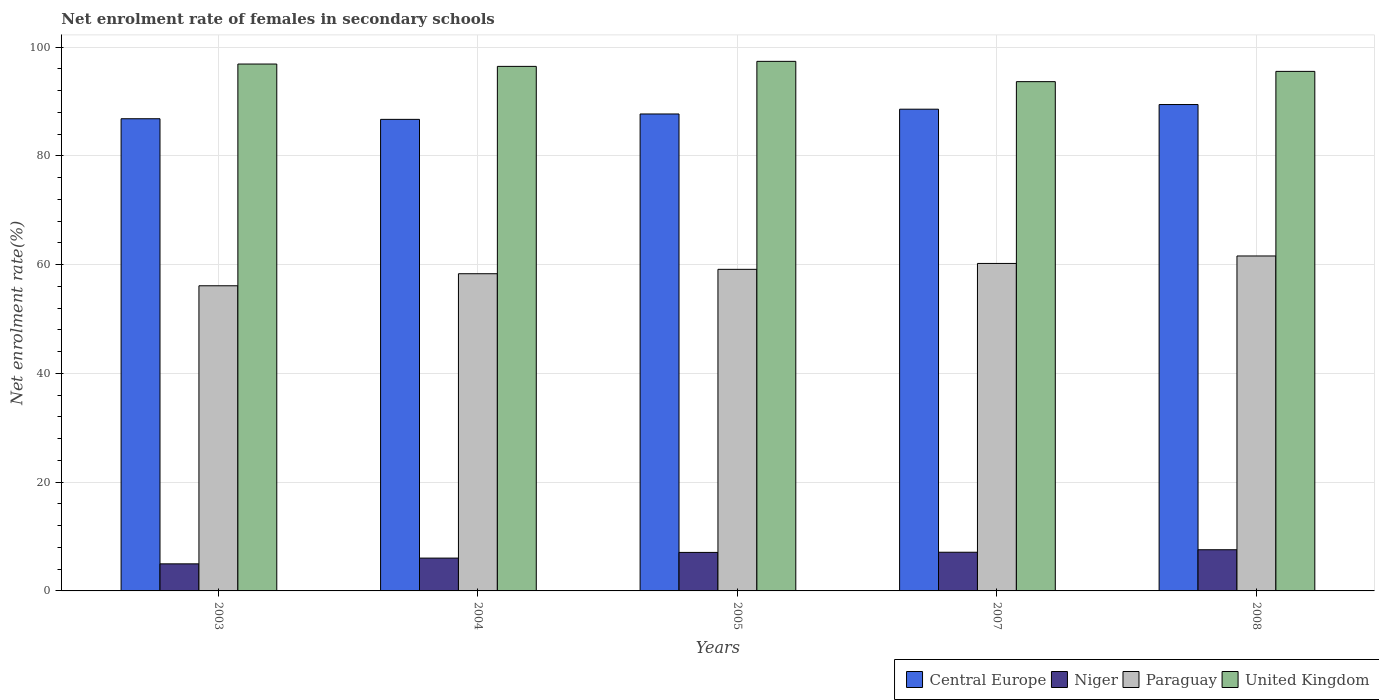Are the number of bars on each tick of the X-axis equal?
Your answer should be very brief. Yes. How many bars are there on the 2nd tick from the right?
Offer a terse response. 4. What is the label of the 4th group of bars from the left?
Your response must be concise. 2007. In how many cases, is the number of bars for a given year not equal to the number of legend labels?
Give a very brief answer. 0. What is the net enrolment rate of females in secondary schools in United Kingdom in 2004?
Offer a terse response. 96.44. Across all years, what is the maximum net enrolment rate of females in secondary schools in Paraguay?
Give a very brief answer. 61.59. Across all years, what is the minimum net enrolment rate of females in secondary schools in Paraguay?
Your answer should be compact. 56.11. In which year was the net enrolment rate of females in secondary schools in United Kingdom minimum?
Provide a short and direct response. 2007. What is the total net enrolment rate of females in secondary schools in United Kingdom in the graph?
Keep it short and to the point. 479.85. What is the difference between the net enrolment rate of females in secondary schools in United Kingdom in 2007 and that in 2008?
Provide a succinct answer. -1.89. What is the difference between the net enrolment rate of females in secondary schools in Paraguay in 2005 and the net enrolment rate of females in secondary schools in Niger in 2004?
Keep it short and to the point. 53.09. What is the average net enrolment rate of females in secondary schools in Central Europe per year?
Make the answer very short. 87.84. In the year 2003, what is the difference between the net enrolment rate of females in secondary schools in Paraguay and net enrolment rate of females in secondary schools in Niger?
Make the answer very short. 51.13. In how many years, is the net enrolment rate of females in secondary schools in Central Europe greater than 72 %?
Provide a succinct answer. 5. What is the ratio of the net enrolment rate of females in secondary schools in Niger in 2004 to that in 2007?
Provide a short and direct response. 0.85. Is the net enrolment rate of females in secondary schools in Paraguay in 2004 less than that in 2005?
Offer a terse response. Yes. Is the difference between the net enrolment rate of females in secondary schools in Paraguay in 2004 and 2005 greater than the difference between the net enrolment rate of females in secondary schools in Niger in 2004 and 2005?
Your answer should be very brief. Yes. What is the difference between the highest and the second highest net enrolment rate of females in secondary schools in Niger?
Your answer should be very brief. 0.46. What is the difference between the highest and the lowest net enrolment rate of females in secondary schools in Central Europe?
Your answer should be compact. 2.73. Is the sum of the net enrolment rate of females in secondary schools in Paraguay in 2005 and 2007 greater than the maximum net enrolment rate of females in secondary schools in Niger across all years?
Your answer should be very brief. Yes. Is it the case that in every year, the sum of the net enrolment rate of females in secondary schools in United Kingdom and net enrolment rate of females in secondary schools in Paraguay is greater than the sum of net enrolment rate of females in secondary schools in Niger and net enrolment rate of females in secondary schools in Central Europe?
Offer a very short reply. Yes. What does the 2nd bar from the left in 2008 represents?
Give a very brief answer. Niger. What does the 3rd bar from the right in 2003 represents?
Provide a short and direct response. Niger. How many years are there in the graph?
Your answer should be very brief. 5. What is the difference between two consecutive major ticks on the Y-axis?
Provide a short and direct response. 20. Are the values on the major ticks of Y-axis written in scientific E-notation?
Offer a very short reply. No. Does the graph contain grids?
Ensure brevity in your answer.  Yes. How many legend labels are there?
Your answer should be very brief. 4. What is the title of the graph?
Offer a very short reply. Net enrolment rate of females in secondary schools. Does "Central Europe" appear as one of the legend labels in the graph?
Provide a succinct answer. Yes. What is the label or title of the Y-axis?
Provide a succinct answer. Net enrolment rate(%). What is the Net enrolment rate(%) of Central Europe in 2003?
Ensure brevity in your answer.  86.82. What is the Net enrolment rate(%) of Niger in 2003?
Your response must be concise. 4.98. What is the Net enrolment rate(%) in Paraguay in 2003?
Provide a succinct answer. 56.11. What is the Net enrolment rate(%) in United Kingdom in 2003?
Your answer should be very brief. 96.88. What is the Net enrolment rate(%) in Central Europe in 2004?
Offer a very short reply. 86.7. What is the Net enrolment rate(%) in Niger in 2004?
Provide a short and direct response. 6.04. What is the Net enrolment rate(%) of Paraguay in 2004?
Keep it short and to the point. 58.32. What is the Net enrolment rate(%) in United Kingdom in 2004?
Your answer should be very brief. 96.44. What is the Net enrolment rate(%) of Central Europe in 2005?
Your answer should be very brief. 87.69. What is the Net enrolment rate(%) in Niger in 2005?
Give a very brief answer. 7.08. What is the Net enrolment rate(%) in Paraguay in 2005?
Offer a very short reply. 59.13. What is the Net enrolment rate(%) in United Kingdom in 2005?
Give a very brief answer. 97.37. What is the Net enrolment rate(%) in Central Europe in 2007?
Your answer should be very brief. 88.57. What is the Net enrolment rate(%) of Niger in 2007?
Ensure brevity in your answer.  7.11. What is the Net enrolment rate(%) of Paraguay in 2007?
Ensure brevity in your answer.  60.21. What is the Net enrolment rate(%) of United Kingdom in 2007?
Provide a short and direct response. 93.64. What is the Net enrolment rate(%) of Central Europe in 2008?
Provide a short and direct response. 89.43. What is the Net enrolment rate(%) of Niger in 2008?
Offer a very short reply. 7.57. What is the Net enrolment rate(%) of Paraguay in 2008?
Offer a very short reply. 61.59. What is the Net enrolment rate(%) of United Kingdom in 2008?
Your answer should be compact. 95.53. Across all years, what is the maximum Net enrolment rate(%) of Central Europe?
Your response must be concise. 89.43. Across all years, what is the maximum Net enrolment rate(%) of Niger?
Make the answer very short. 7.57. Across all years, what is the maximum Net enrolment rate(%) of Paraguay?
Your answer should be very brief. 61.59. Across all years, what is the maximum Net enrolment rate(%) in United Kingdom?
Provide a short and direct response. 97.37. Across all years, what is the minimum Net enrolment rate(%) of Central Europe?
Make the answer very short. 86.7. Across all years, what is the minimum Net enrolment rate(%) in Niger?
Give a very brief answer. 4.98. Across all years, what is the minimum Net enrolment rate(%) of Paraguay?
Offer a terse response. 56.11. Across all years, what is the minimum Net enrolment rate(%) of United Kingdom?
Keep it short and to the point. 93.64. What is the total Net enrolment rate(%) of Central Europe in the graph?
Provide a succinct answer. 439.22. What is the total Net enrolment rate(%) of Niger in the graph?
Offer a terse response. 32.78. What is the total Net enrolment rate(%) of Paraguay in the graph?
Provide a short and direct response. 295.35. What is the total Net enrolment rate(%) of United Kingdom in the graph?
Provide a short and direct response. 479.85. What is the difference between the Net enrolment rate(%) of Central Europe in 2003 and that in 2004?
Ensure brevity in your answer.  0.12. What is the difference between the Net enrolment rate(%) in Niger in 2003 and that in 2004?
Give a very brief answer. -1.06. What is the difference between the Net enrolment rate(%) in Paraguay in 2003 and that in 2004?
Your answer should be compact. -2.22. What is the difference between the Net enrolment rate(%) in United Kingdom in 2003 and that in 2004?
Your answer should be compact. 0.43. What is the difference between the Net enrolment rate(%) of Central Europe in 2003 and that in 2005?
Your answer should be compact. -0.88. What is the difference between the Net enrolment rate(%) of Niger in 2003 and that in 2005?
Offer a very short reply. -2.1. What is the difference between the Net enrolment rate(%) of Paraguay in 2003 and that in 2005?
Provide a short and direct response. -3.02. What is the difference between the Net enrolment rate(%) in United Kingdom in 2003 and that in 2005?
Keep it short and to the point. -0.49. What is the difference between the Net enrolment rate(%) in Central Europe in 2003 and that in 2007?
Your response must be concise. -1.76. What is the difference between the Net enrolment rate(%) of Niger in 2003 and that in 2007?
Keep it short and to the point. -2.13. What is the difference between the Net enrolment rate(%) of Paraguay in 2003 and that in 2007?
Your answer should be compact. -4.1. What is the difference between the Net enrolment rate(%) in United Kingdom in 2003 and that in 2007?
Offer a very short reply. 3.24. What is the difference between the Net enrolment rate(%) of Central Europe in 2003 and that in 2008?
Offer a terse response. -2.61. What is the difference between the Net enrolment rate(%) in Niger in 2003 and that in 2008?
Provide a short and direct response. -2.6. What is the difference between the Net enrolment rate(%) of Paraguay in 2003 and that in 2008?
Offer a terse response. -5.48. What is the difference between the Net enrolment rate(%) in United Kingdom in 2003 and that in 2008?
Ensure brevity in your answer.  1.35. What is the difference between the Net enrolment rate(%) of Central Europe in 2004 and that in 2005?
Your answer should be compact. -0.99. What is the difference between the Net enrolment rate(%) in Niger in 2004 and that in 2005?
Offer a very short reply. -1.05. What is the difference between the Net enrolment rate(%) in Paraguay in 2004 and that in 2005?
Keep it short and to the point. -0.81. What is the difference between the Net enrolment rate(%) in United Kingdom in 2004 and that in 2005?
Your response must be concise. -0.93. What is the difference between the Net enrolment rate(%) in Central Europe in 2004 and that in 2007?
Your answer should be very brief. -1.87. What is the difference between the Net enrolment rate(%) of Niger in 2004 and that in 2007?
Offer a very short reply. -1.08. What is the difference between the Net enrolment rate(%) of Paraguay in 2004 and that in 2007?
Your response must be concise. -1.89. What is the difference between the Net enrolment rate(%) of United Kingdom in 2004 and that in 2007?
Your response must be concise. 2.81. What is the difference between the Net enrolment rate(%) in Central Europe in 2004 and that in 2008?
Offer a terse response. -2.73. What is the difference between the Net enrolment rate(%) of Niger in 2004 and that in 2008?
Provide a short and direct response. -1.54. What is the difference between the Net enrolment rate(%) in Paraguay in 2004 and that in 2008?
Your answer should be compact. -3.26. What is the difference between the Net enrolment rate(%) of United Kingdom in 2004 and that in 2008?
Your answer should be compact. 0.92. What is the difference between the Net enrolment rate(%) in Central Europe in 2005 and that in 2007?
Your answer should be very brief. -0.88. What is the difference between the Net enrolment rate(%) in Niger in 2005 and that in 2007?
Your answer should be compact. -0.03. What is the difference between the Net enrolment rate(%) in Paraguay in 2005 and that in 2007?
Offer a terse response. -1.08. What is the difference between the Net enrolment rate(%) of United Kingdom in 2005 and that in 2007?
Make the answer very short. 3.73. What is the difference between the Net enrolment rate(%) of Central Europe in 2005 and that in 2008?
Offer a very short reply. -1.74. What is the difference between the Net enrolment rate(%) of Niger in 2005 and that in 2008?
Give a very brief answer. -0.49. What is the difference between the Net enrolment rate(%) of Paraguay in 2005 and that in 2008?
Provide a succinct answer. -2.46. What is the difference between the Net enrolment rate(%) of United Kingdom in 2005 and that in 2008?
Keep it short and to the point. 1.84. What is the difference between the Net enrolment rate(%) of Central Europe in 2007 and that in 2008?
Offer a very short reply. -0.86. What is the difference between the Net enrolment rate(%) of Niger in 2007 and that in 2008?
Your response must be concise. -0.46. What is the difference between the Net enrolment rate(%) of Paraguay in 2007 and that in 2008?
Offer a very short reply. -1.38. What is the difference between the Net enrolment rate(%) in United Kingdom in 2007 and that in 2008?
Provide a succinct answer. -1.89. What is the difference between the Net enrolment rate(%) in Central Europe in 2003 and the Net enrolment rate(%) in Niger in 2004?
Provide a succinct answer. 80.78. What is the difference between the Net enrolment rate(%) of Central Europe in 2003 and the Net enrolment rate(%) of Paraguay in 2004?
Your response must be concise. 28.5. What is the difference between the Net enrolment rate(%) of Central Europe in 2003 and the Net enrolment rate(%) of United Kingdom in 2004?
Provide a succinct answer. -9.63. What is the difference between the Net enrolment rate(%) in Niger in 2003 and the Net enrolment rate(%) in Paraguay in 2004?
Your answer should be compact. -53.35. What is the difference between the Net enrolment rate(%) of Niger in 2003 and the Net enrolment rate(%) of United Kingdom in 2004?
Provide a short and direct response. -91.47. What is the difference between the Net enrolment rate(%) in Paraguay in 2003 and the Net enrolment rate(%) in United Kingdom in 2004?
Offer a very short reply. -40.34. What is the difference between the Net enrolment rate(%) of Central Europe in 2003 and the Net enrolment rate(%) of Niger in 2005?
Make the answer very short. 79.74. What is the difference between the Net enrolment rate(%) in Central Europe in 2003 and the Net enrolment rate(%) in Paraguay in 2005?
Your answer should be compact. 27.69. What is the difference between the Net enrolment rate(%) of Central Europe in 2003 and the Net enrolment rate(%) of United Kingdom in 2005?
Your response must be concise. -10.55. What is the difference between the Net enrolment rate(%) in Niger in 2003 and the Net enrolment rate(%) in Paraguay in 2005?
Provide a succinct answer. -54.15. What is the difference between the Net enrolment rate(%) in Niger in 2003 and the Net enrolment rate(%) in United Kingdom in 2005?
Keep it short and to the point. -92.39. What is the difference between the Net enrolment rate(%) in Paraguay in 2003 and the Net enrolment rate(%) in United Kingdom in 2005?
Your answer should be compact. -41.26. What is the difference between the Net enrolment rate(%) of Central Europe in 2003 and the Net enrolment rate(%) of Niger in 2007?
Provide a short and direct response. 79.71. What is the difference between the Net enrolment rate(%) in Central Europe in 2003 and the Net enrolment rate(%) in Paraguay in 2007?
Your answer should be compact. 26.61. What is the difference between the Net enrolment rate(%) in Central Europe in 2003 and the Net enrolment rate(%) in United Kingdom in 2007?
Provide a short and direct response. -6.82. What is the difference between the Net enrolment rate(%) of Niger in 2003 and the Net enrolment rate(%) of Paraguay in 2007?
Offer a very short reply. -55.23. What is the difference between the Net enrolment rate(%) of Niger in 2003 and the Net enrolment rate(%) of United Kingdom in 2007?
Your response must be concise. -88.66. What is the difference between the Net enrolment rate(%) of Paraguay in 2003 and the Net enrolment rate(%) of United Kingdom in 2007?
Provide a short and direct response. -37.53. What is the difference between the Net enrolment rate(%) of Central Europe in 2003 and the Net enrolment rate(%) of Niger in 2008?
Ensure brevity in your answer.  79.25. What is the difference between the Net enrolment rate(%) in Central Europe in 2003 and the Net enrolment rate(%) in Paraguay in 2008?
Your answer should be compact. 25.23. What is the difference between the Net enrolment rate(%) in Central Europe in 2003 and the Net enrolment rate(%) in United Kingdom in 2008?
Your answer should be very brief. -8.71. What is the difference between the Net enrolment rate(%) in Niger in 2003 and the Net enrolment rate(%) in Paraguay in 2008?
Give a very brief answer. -56.61. What is the difference between the Net enrolment rate(%) in Niger in 2003 and the Net enrolment rate(%) in United Kingdom in 2008?
Provide a succinct answer. -90.55. What is the difference between the Net enrolment rate(%) in Paraguay in 2003 and the Net enrolment rate(%) in United Kingdom in 2008?
Give a very brief answer. -39.42. What is the difference between the Net enrolment rate(%) in Central Europe in 2004 and the Net enrolment rate(%) in Niger in 2005?
Give a very brief answer. 79.62. What is the difference between the Net enrolment rate(%) in Central Europe in 2004 and the Net enrolment rate(%) in Paraguay in 2005?
Provide a succinct answer. 27.57. What is the difference between the Net enrolment rate(%) in Central Europe in 2004 and the Net enrolment rate(%) in United Kingdom in 2005?
Provide a short and direct response. -10.67. What is the difference between the Net enrolment rate(%) in Niger in 2004 and the Net enrolment rate(%) in Paraguay in 2005?
Make the answer very short. -53.09. What is the difference between the Net enrolment rate(%) in Niger in 2004 and the Net enrolment rate(%) in United Kingdom in 2005?
Ensure brevity in your answer.  -91.33. What is the difference between the Net enrolment rate(%) of Paraguay in 2004 and the Net enrolment rate(%) of United Kingdom in 2005?
Your response must be concise. -39.05. What is the difference between the Net enrolment rate(%) in Central Europe in 2004 and the Net enrolment rate(%) in Niger in 2007?
Make the answer very short. 79.59. What is the difference between the Net enrolment rate(%) of Central Europe in 2004 and the Net enrolment rate(%) of Paraguay in 2007?
Provide a short and direct response. 26.49. What is the difference between the Net enrolment rate(%) in Central Europe in 2004 and the Net enrolment rate(%) in United Kingdom in 2007?
Your answer should be compact. -6.94. What is the difference between the Net enrolment rate(%) of Niger in 2004 and the Net enrolment rate(%) of Paraguay in 2007?
Your answer should be compact. -54.18. What is the difference between the Net enrolment rate(%) in Niger in 2004 and the Net enrolment rate(%) in United Kingdom in 2007?
Offer a terse response. -87.6. What is the difference between the Net enrolment rate(%) of Paraguay in 2004 and the Net enrolment rate(%) of United Kingdom in 2007?
Offer a very short reply. -35.32. What is the difference between the Net enrolment rate(%) in Central Europe in 2004 and the Net enrolment rate(%) in Niger in 2008?
Offer a terse response. 79.13. What is the difference between the Net enrolment rate(%) in Central Europe in 2004 and the Net enrolment rate(%) in Paraguay in 2008?
Keep it short and to the point. 25.12. What is the difference between the Net enrolment rate(%) of Central Europe in 2004 and the Net enrolment rate(%) of United Kingdom in 2008?
Make the answer very short. -8.82. What is the difference between the Net enrolment rate(%) of Niger in 2004 and the Net enrolment rate(%) of Paraguay in 2008?
Your response must be concise. -55.55. What is the difference between the Net enrolment rate(%) of Niger in 2004 and the Net enrolment rate(%) of United Kingdom in 2008?
Ensure brevity in your answer.  -89.49. What is the difference between the Net enrolment rate(%) in Paraguay in 2004 and the Net enrolment rate(%) in United Kingdom in 2008?
Make the answer very short. -37.2. What is the difference between the Net enrolment rate(%) in Central Europe in 2005 and the Net enrolment rate(%) in Niger in 2007?
Offer a very short reply. 80.58. What is the difference between the Net enrolment rate(%) in Central Europe in 2005 and the Net enrolment rate(%) in Paraguay in 2007?
Ensure brevity in your answer.  27.48. What is the difference between the Net enrolment rate(%) in Central Europe in 2005 and the Net enrolment rate(%) in United Kingdom in 2007?
Provide a short and direct response. -5.94. What is the difference between the Net enrolment rate(%) in Niger in 2005 and the Net enrolment rate(%) in Paraguay in 2007?
Make the answer very short. -53.13. What is the difference between the Net enrolment rate(%) in Niger in 2005 and the Net enrolment rate(%) in United Kingdom in 2007?
Provide a short and direct response. -86.56. What is the difference between the Net enrolment rate(%) in Paraguay in 2005 and the Net enrolment rate(%) in United Kingdom in 2007?
Offer a terse response. -34.51. What is the difference between the Net enrolment rate(%) in Central Europe in 2005 and the Net enrolment rate(%) in Niger in 2008?
Make the answer very short. 80.12. What is the difference between the Net enrolment rate(%) in Central Europe in 2005 and the Net enrolment rate(%) in Paraguay in 2008?
Provide a short and direct response. 26.11. What is the difference between the Net enrolment rate(%) of Central Europe in 2005 and the Net enrolment rate(%) of United Kingdom in 2008?
Ensure brevity in your answer.  -7.83. What is the difference between the Net enrolment rate(%) of Niger in 2005 and the Net enrolment rate(%) of Paraguay in 2008?
Provide a succinct answer. -54.51. What is the difference between the Net enrolment rate(%) of Niger in 2005 and the Net enrolment rate(%) of United Kingdom in 2008?
Your answer should be very brief. -88.44. What is the difference between the Net enrolment rate(%) in Paraguay in 2005 and the Net enrolment rate(%) in United Kingdom in 2008?
Your response must be concise. -36.4. What is the difference between the Net enrolment rate(%) in Central Europe in 2007 and the Net enrolment rate(%) in Niger in 2008?
Make the answer very short. 81. What is the difference between the Net enrolment rate(%) of Central Europe in 2007 and the Net enrolment rate(%) of Paraguay in 2008?
Give a very brief answer. 26.99. What is the difference between the Net enrolment rate(%) in Central Europe in 2007 and the Net enrolment rate(%) in United Kingdom in 2008?
Offer a very short reply. -6.95. What is the difference between the Net enrolment rate(%) of Niger in 2007 and the Net enrolment rate(%) of Paraguay in 2008?
Give a very brief answer. -54.48. What is the difference between the Net enrolment rate(%) in Niger in 2007 and the Net enrolment rate(%) in United Kingdom in 2008?
Your answer should be very brief. -88.41. What is the difference between the Net enrolment rate(%) in Paraguay in 2007 and the Net enrolment rate(%) in United Kingdom in 2008?
Your answer should be very brief. -35.31. What is the average Net enrolment rate(%) of Central Europe per year?
Make the answer very short. 87.84. What is the average Net enrolment rate(%) in Niger per year?
Your response must be concise. 6.56. What is the average Net enrolment rate(%) of Paraguay per year?
Provide a succinct answer. 59.07. What is the average Net enrolment rate(%) in United Kingdom per year?
Keep it short and to the point. 95.97. In the year 2003, what is the difference between the Net enrolment rate(%) of Central Europe and Net enrolment rate(%) of Niger?
Give a very brief answer. 81.84. In the year 2003, what is the difference between the Net enrolment rate(%) in Central Europe and Net enrolment rate(%) in Paraguay?
Your answer should be compact. 30.71. In the year 2003, what is the difference between the Net enrolment rate(%) of Central Europe and Net enrolment rate(%) of United Kingdom?
Your answer should be compact. -10.06. In the year 2003, what is the difference between the Net enrolment rate(%) of Niger and Net enrolment rate(%) of Paraguay?
Provide a succinct answer. -51.13. In the year 2003, what is the difference between the Net enrolment rate(%) in Niger and Net enrolment rate(%) in United Kingdom?
Make the answer very short. -91.9. In the year 2003, what is the difference between the Net enrolment rate(%) of Paraguay and Net enrolment rate(%) of United Kingdom?
Offer a terse response. -40.77. In the year 2004, what is the difference between the Net enrolment rate(%) of Central Europe and Net enrolment rate(%) of Niger?
Provide a succinct answer. 80.67. In the year 2004, what is the difference between the Net enrolment rate(%) of Central Europe and Net enrolment rate(%) of Paraguay?
Provide a short and direct response. 28.38. In the year 2004, what is the difference between the Net enrolment rate(%) of Central Europe and Net enrolment rate(%) of United Kingdom?
Your response must be concise. -9.74. In the year 2004, what is the difference between the Net enrolment rate(%) of Niger and Net enrolment rate(%) of Paraguay?
Your answer should be very brief. -52.29. In the year 2004, what is the difference between the Net enrolment rate(%) of Niger and Net enrolment rate(%) of United Kingdom?
Ensure brevity in your answer.  -90.41. In the year 2004, what is the difference between the Net enrolment rate(%) of Paraguay and Net enrolment rate(%) of United Kingdom?
Offer a terse response. -38.12. In the year 2005, what is the difference between the Net enrolment rate(%) of Central Europe and Net enrolment rate(%) of Niger?
Ensure brevity in your answer.  80.61. In the year 2005, what is the difference between the Net enrolment rate(%) in Central Europe and Net enrolment rate(%) in Paraguay?
Offer a terse response. 28.56. In the year 2005, what is the difference between the Net enrolment rate(%) of Central Europe and Net enrolment rate(%) of United Kingdom?
Your answer should be very brief. -9.68. In the year 2005, what is the difference between the Net enrolment rate(%) in Niger and Net enrolment rate(%) in Paraguay?
Your response must be concise. -52.05. In the year 2005, what is the difference between the Net enrolment rate(%) of Niger and Net enrolment rate(%) of United Kingdom?
Provide a succinct answer. -90.29. In the year 2005, what is the difference between the Net enrolment rate(%) in Paraguay and Net enrolment rate(%) in United Kingdom?
Provide a short and direct response. -38.24. In the year 2007, what is the difference between the Net enrolment rate(%) of Central Europe and Net enrolment rate(%) of Niger?
Your answer should be compact. 81.46. In the year 2007, what is the difference between the Net enrolment rate(%) in Central Europe and Net enrolment rate(%) in Paraguay?
Offer a terse response. 28.36. In the year 2007, what is the difference between the Net enrolment rate(%) of Central Europe and Net enrolment rate(%) of United Kingdom?
Make the answer very short. -5.06. In the year 2007, what is the difference between the Net enrolment rate(%) in Niger and Net enrolment rate(%) in Paraguay?
Give a very brief answer. -53.1. In the year 2007, what is the difference between the Net enrolment rate(%) in Niger and Net enrolment rate(%) in United Kingdom?
Your answer should be compact. -86.53. In the year 2007, what is the difference between the Net enrolment rate(%) of Paraguay and Net enrolment rate(%) of United Kingdom?
Provide a short and direct response. -33.43. In the year 2008, what is the difference between the Net enrolment rate(%) in Central Europe and Net enrolment rate(%) in Niger?
Your answer should be very brief. 81.86. In the year 2008, what is the difference between the Net enrolment rate(%) in Central Europe and Net enrolment rate(%) in Paraguay?
Your answer should be very brief. 27.84. In the year 2008, what is the difference between the Net enrolment rate(%) of Central Europe and Net enrolment rate(%) of United Kingdom?
Your answer should be compact. -6.1. In the year 2008, what is the difference between the Net enrolment rate(%) in Niger and Net enrolment rate(%) in Paraguay?
Keep it short and to the point. -54.01. In the year 2008, what is the difference between the Net enrolment rate(%) of Niger and Net enrolment rate(%) of United Kingdom?
Your answer should be very brief. -87.95. In the year 2008, what is the difference between the Net enrolment rate(%) in Paraguay and Net enrolment rate(%) in United Kingdom?
Your answer should be very brief. -33.94. What is the ratio of the Net enrolment rate(%) of Central Europe in 2003 to that in 2004?
Your answer should be very brief. 1. What is the ratio of the Net enrolment rate(%) in Niger in 2003 to that in 2004?
Offer a terse response. 0.82. What is the ratio of the Net enrolment rate(%) in Paraguay in 2003 to that in 2004?
Offer a very short reply. 0.96. What is the ratio of the Net enrolment rate(%) of United Kingdom in 2003 to that in 2004?
Your answer should be very brief. 1. What is the ratio of the Net enrolment rate(%) in Central Europe in 2003 to that in 2005?
Offer a very short reply. 0.99. What is the ratio of the Net enrolment rate(%) of Niger in 2003 to that in 2005?
Your answer should be compact. 0.7. What is the ratio of the Net enrolment rate(%) of Paraguay in 2003 to that in 2005?
Your answer should be very brief. 0.95. What is the ratio of the Net enrolment rate(%) in Central Europe in 2003 to that in 2007?
Ensure brevity in your answer.  0.98. What is the ratio of the Net enrolment rate(%) of Niger in 2003 to that in 2007?
Your answer should be very brief. 0.7. What is the ratio of the Net enrolment rate(%) in Paraguay in 2003 to that in 2007?
Keep it short and to the point. 0.93. What is the ratio of the Net enrolment rate(%) in United Kingdom in 2003 to that in 2007?
Provide a short and direct response. 1.03. What is the ratio of the Net enrolment rate(%) of Central Europe in 2003 to that in 2008?
Keep it short and to the point. 0.97. What is the ratio of the Net enrolment rate(%) in Niger in 2003 to that in 2008?
Make the answer very short. 0.66. What is the ratio of the Net enrolment rate(%) in Paraguay in 2003 to that in 2008?
Provide a succinct answer. 0.91. What is the ratio of the Net enrolment rate(%) of United Kingdom in 2003 to that in 2008?
Keep it short and to the point. 1.01. What is the ratio of the Net enrolment rate(%) in Central Europe in 2004 to that in 2005?
Keep it short and to the point. 0.99. What is the ratio of the Net enrolment rate(%) of Niger in 2004 to that in 2005?
Give a very brief answer. 0.85. What is the ratio of the Net enrolment rate(%) of Paraguay in 2004 to that in 2005?
Provide a short and direct response. 0.99. What is the ratio of the Net enrolment rate(%) of Central Europe in 2004 to that in 2007?
Give a very brief answer. 0.98. What is the ratio of the Net enrolment rate(%) in Niger in 2004 to that in 2007?
Ensure brevity in your answer.  0.85. What is the ratio of the Net enrolment rate(%) of Paraguay in 2004 to that in 2007?
Ensure brevity in your answer.  0.97. What is the ratio of the Net enrolment rate(%) of United Kingdom in 2004 to that in 2007?
Offer a very short reply. 1.03. What is the ratio of the Net enrolment rate(%) in Central Europe in 2004 to that in 2008?
Offer a terse response. 0.97. What is the ratio of the Net enrolment rate(%) of Niger in 2004 to that in 2008?
Your response must be concise. 0.8. What is the ratio of the Net enrolment rate(%) of Paraguay in 2004 to that in 2008?
Provide a short and direct response. 0.95. What is the ratio of the Net enrolment rate(%) of United Kingdom in 2004 to that in 2008?
Provide a succinct answer. 1.01. What is the ratio of the Net enrolment rate(%) in Central Europe in 2005 to that in 2007?
Ensure brevity in your answer.  0.99. What is the ratio of the Net enrolment rate(%) in United Kingdom in 2005 to that in 2007?
Make the answer very short. 1.04. What is the ratio of the Net enrolment rate(%) of Central Europe in 2005 to that in 2008?
Give a very brief answer. 0.98. What is the ratio of the Net enrolment rate(%) in Niger in 2005 to that in 2008?
Your answer should be very brief. 0.94. What is the ratio of the Net enrolment rate(%) of Paraguay in 2005 to that in 2008?
Your answer should be compact. 0.96. What is the ratio of the Net enrolment rate(%) of United Kingdom in 2005 to that in 2008?
Give a very brief answer. 1.02. What is the ratio of the Net enrolment rate(%) in Niger in 2007 to that in 2008?
Make the answer very short. 0.94. What is the ratio of the Net enrolment rate(%) in Paraguay in 2007 to that in 2008?
Make the answer very short. 0.98. What is the ratio of the Net enrolment rate(%) of United Kingdom in 2007 to that in 2008?
Keep it short and to the point. 0.98. What is the difference between the highest and the second highest Net enrolment rate(%) in Central Europe?
Your response must be concise. 0.86. What is the difference between the highest and the second highest Net enrolment rate(%) of Niger?
Keep it short and to the point. 0.46. What is the difference between the highest and the second highest Net enrolment rate(%) of Paraguay?
Provide a short and direct response. 1.38. What is the difference between the highest and the second highest Net enrolment rate(%) of United Kingdom?
Provide a short and direct response. 0.49. What is the difference between the highest and the lowest Net enrolment rate(%) of Central Europe?
Offer a very short reply. 2.73. What is the difference between the highest and the lowest Net enrolment rate(%) in Niger?
Ensure brevity in your answer.  2.6. What is the difference between the highest and the lowest Net enrolment rate(%) in Paraguay?
Provide a succinct answer. 5.48. What is the difference between the highest and the lowest Net enrolment rate(%) of United Kingdom?
Ensure brevity in your answer.  3.73. 